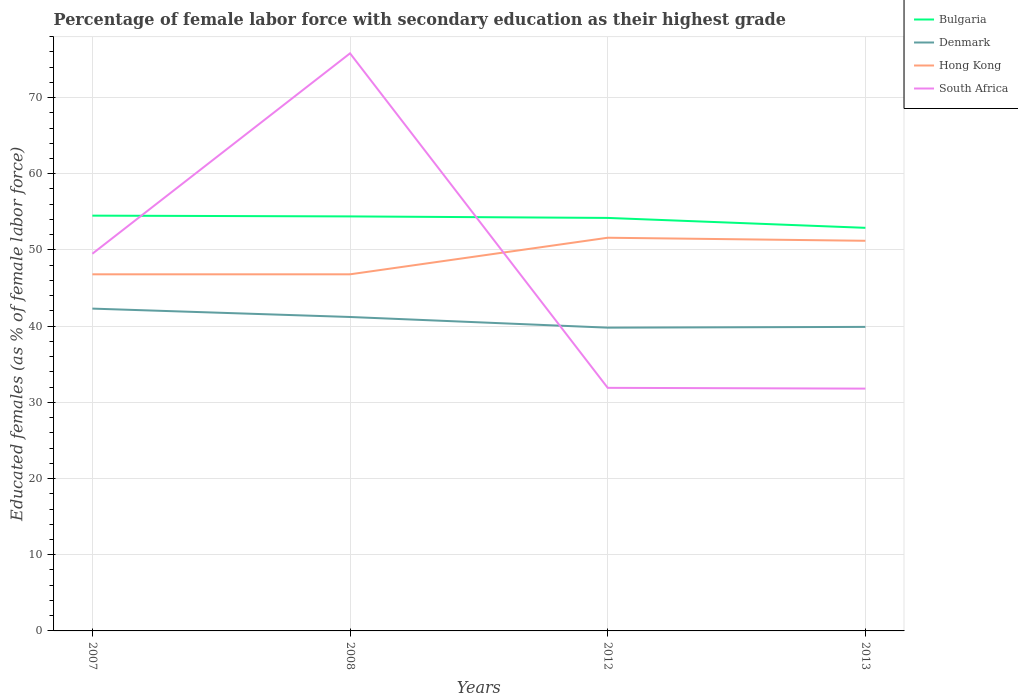How many different coloured lines are there?
Ensure brevity in your answer.  4. Across all years, what is the maximum percentage of female labor force with secondary education in Denmark?
Provide a succinct answer. 39.8. In which year was the percentage of female labor force with secondary education in Denmark maximum?
Your answer should be very brief. 2012. What is the total percentage of female labor force with secondary education in Hong Kong in the graph?
Offer a terse response. -4.4. What is the difference between the highest and the lowest percentage of female labor force with secondary education in South Africa?
Ensure brevity in your answer.  2. How many years are there in the graph?
Your answer should be compact. 4. Where does the legend appear in the graph?
Make the answer very short. Top right. How many legend labels are there?
Offer a terse response. 4. What is the title of the graph?
Give a very brief answer. Percentage of female labor force with secondary education as their highest grade. What is the label or title of the Y-axis?
Keep it short and to the point. Educated females (as % of female labor force). What is the Educated females (as % of female labor force) in Bulgaria in 2007?
Your response must be concise. 54.5. What is the Educated females (as % of female labor force) in Denmark in 2007?
Provide a short and direct response. 42.3. What is the Educated females (as % of female labor force) in Hong Kong in 2007?
Make the answer very short. 46.8. What is the Educated females (as % of female labor force) in South Africa in 2007?
Keep it short and to the point. 49.5. What is the Educated females (as % of female labor force) in Bulgaria in 2008?
Keep it short and to the point. 54.4. What is the Educated females (as % of female labor force) in Denmark in 2008?
Keep it short and to the point. 41.2. What is the Educated females (as % of female labor force) of Hong Kong in 2008?
Offer a terse response. 46.8. What is the Educated females (as % of female labor force) in South Africa in 2008?
Give a very brief answer. 75.8. What is the Educated females (as % of female labor force) of Bulgaria in 2012?
Ensure brevity in your answer.  54.2. What is the Educated females (as % of female labor force) in Denmark in 2012?
Offer a very short reply. 39.8. What is the Educated females (as % of female labor force) of Hong Kong in 2012?
Make the answer very short. 51.6. What is the Educated females (as % of female labor force) in South Africa in 2012?
Keep it short and to the point. 31.9. What is the Educated females (as % of female labor force) of Bulgaria in 2013?
Give a very brief answer. 52.9. What is the Educated females (as % of female labor force) in Denmark in 2013?
Keep it short and to the point. 39.9. What is the Educated females (as % of female labor force) of Hong Kong in 2013?
Give a very brief answer. 51.2. What is the Educated females (as % of female labor force) in South Africa in 2013?
Your response must be concise. 31.8. Across all years, what is the maximum Educated females (as % of female labor force) in Bulgaria?
Your answer should be very brief. 54.5. Across all years, what is the maximum Educated females (as % of female labor force) of Denmark?
Offer a very short reply. 42.3. Across all years, what is the maximum Educated females (as % of female labor force) in Hong Kong?
Your response must be concise. 51.6. Across all years, what is the maximum Educated females (as % of female labor force) in South Africa?
Keep it short and to the point. 75.8. Across all years, what is the minimum Educated females (as % of female labor force) of Bulgaria?
Ensure brevity in your answer.  52.9. Across all years, what is the minimum Educated females (as % of female labor force) in Denmark?
Provide a succinct answer. 39.8. Across all years, what is the minimum Educated females (as % of female labor force) of Hong Kong?
Make the answer very short. 46.8. Across all years, what is the minimum Educated females (as % of female labor force) of South Africa?
Your response must be concise. 31.8. What is the total Educated females (as % of female labor force) in Bulgaria in the graph?
Give a very brief answer. 216. What is the total Educated females (as % of female labor force) of Denmark in the graph?
Your answer should be compact. 163.2. What is the total Educated females (as % of female labor force) of Hong Kong in the graph?
Your answer should be compact. 196.4. What is the total Educated females (as % of female labor force) in South Africa in the graph?
Keep it short and to the point. 189. What is the difference between the Educated females (as % of female labor force) in Bulgaria in 2007 and that in 2008?
Your answer should be compact. 0.1. What is the difference between the Educated females (as % of female labor force) of Denmark in 2007 and that in 2008?
Your answer should be very brief. 1.1. What is the difference between the Educated females (as % of female labor force) of Hong Kong in 2007 and that in 2008?
Keep it short and to the point. 0. What is the difference between the Educated females (as % of female labor force) of South Africa in 2007 and that in 2008?
Keep it short and to the point. -26.3. What is the difference between the Educated females (as % of female labor force) of Denmark in 2007 and that in 2012?
Offer a terse response. 2.5. What is the difference between the Educated females (as % of female labor force) of South Africa in 2007 and that in 2012?
Provide a short and direct response. 17.6. What is the difference between the Educated females (as % of female labor force) of South Africa in 2007 and that in 2013?
Provide a short and direct response. 17.7. What is the difference between the Educated females (as % of female labor force) in Bulgaria in 2008 and that in 2012?
Keep it short and to the point. 0.2. What is the difference between the Educated females (as % of female labor force) of South Africa in 2008 and that in 2012?
Provide a short and direct response. 43.9. What is the difference between the Educated females (as % of female labor force) in Bulgaria in 2008 and that in 2013?
Provide a short and direct response. 1.5. What is the difference between the Educated females (as % of female labor force) of Hong Kong in 2008 and that in 2013?
Offer a terse response. -4.4. What is the difference between the Educated females (as % of female labor force) in South Africa in 2008 and that in 2013?
Your answer should be very brief. 44. What is the difference between the Educated females (as % of female labor force) in Bulgaria in 2012 and that in 2013?
Make the answer very short. 1.3. What is the difference between the Educated females (as % of female labor force) in South Africa in 2012 and that in 2013?
Provide a succinct answer. 0.1. What is the difference between the Educated females (as % of female labor force) in Bulgaria in 2007 and the Educated females (as % of female labor force) in Denmark in 2008?
Provide a succinct answer. 13.3. What is the difference between the Educated females (as % of female labor force) of Bulgaria in 2007 and the Educated females (as % of female labor force) of Hong Kong in 2008?
Provide a short and direct response. 7.7. What is the difference between the Educated females (as % of female labor force) in Bulgaria in 2007 and the Educated females (as % of female labor force) in South Africa in 2008?
Offer a very short reply. -21.3. What is the difference between the Educated females (as % of female labor force) of Denmark in 2007 and the Educated females (as % of female labor force) of South Africa in 2008?
Make the answer very short. -33.5. What is the difference between the Educated females (as % of female labor force) of Hong Kong in 2007 and the Educated females (as % of female labor force) of South Africa in 2008?
Your response must be concise. -29. What is the difference between the Educated females (as % of female labor force) in Bulgaria in 2007 and the Educated females (as % of female labor force) in South Africa in 2012?
Keep it short and to the point. 22.6. What is the difference between the Educated females (as % of female labor force) of Hong Kong in 2007 and the Educated females (as % of female labor force) of South Africa in 2012?
Your answer should be compact. 14.9. What is the difference between the Educated females (as % of female labor force) in Bulgaria in 2007 and the Educated females (as % of female labor force) in South Africa in 2013?
Your response must be concise. 22.7. What is the difference between the Educated females (as % of female labor force) in Denmark in 2007 and the Educated females (as % of female labor force) in Hong Kong in 2013?
Provide a succinct answer. -8.9. What is the difference between the Educated females (as % of female labor force) in Denmark in 2007 and the Educated females (as % of female labor force) in South Africa in 2013?
Provide a short and direct response. 10.5. What is the difference between the Educated females (as % of female labor force) of Hong Kong in 2007 and the Educated females (as % of female labor force) of South Africa in 2013?
Your answer should be very brief. 15. What is the difference between the Educated females (as % of female labor force) in Bulgaria in 2008 and the Educated females (as % of female labor force) in Denmark in 2012?
Offer a very short reply. 14.6. What is the difference between the Educated females (as % of female labor force) in Denmark in 2008 and the Educated females (as % of female labor force) in Hong Kong in 2012?
Your response must be concise. -10.4. What is the difference between the Educated females (as % of female labor force) of Denmark in 2008 and the Educated females (as % of female labor force) of South Africa in 2012?
Give a very brief answer. 9.3. What is the difference between the Educated females (as % of female labor force) in Hong Kong in 2008 and the Educated females (as % of female labor force) in South Africa in 2012?
Make the answer very short. 14.9. What is the difference between the Educated females (as % of female labor force) of Bulgaria in 2008 and the Educated females (as % of female labor force) of Hong Kong in 2013?
Your answer should be very brief. 3.2. What is the difference between the Educated females (as % of female labor force) of Bulgaria in 2008 and the Educated females (as % of female labor force) of South Africa in 2013?
Provide a short and direct response. 22.6. What is the difference between the Educated females (as % of female labor force) of Denmark in 2008 and the Educated females (as % of female labor force) of South Africa in 2013?
Your response must be concise. 9.4. What is the difference between the Educated females (as % of female labor force) of Hong Kong in 2008 and the Educated females (as % of female labor force) of South Africa in 2013?
Your response must be concise. 15. What is the difference between the Educated females (as % of female labor force) of Bulgaria in 2012 and the Educated females (as % of female labor force) of Denmark in 2013?
Your answer should be very brief. 14.3. What is the difference between the Educated females (as % of female labor force) in Bulgaria in 2012 and the Educated females (as % of female labor force) in South Africa in 2013?
Keep it short and to the point. 22.4. What is the difference between the Educated females (as % of female labor force) in Hong Kong in 2012 and the Educated females (as % of female labor force) in South Africa in 2013?
Give a very brief answer. 19.8. What is the average Educated females (as % of female labor force) in Bulgaria per year?
Provide a succinct answer. 54. What is the average Educated females (as % of female labor force) in Denmark per year?
Keep it short and to the point. 40.8. What is the average Educated females (as % of female labor force) in Hong Kong per year?
Provide a succinct answer. 49.1. What is the average Educated females (as % of female labor force) of South Africa per year?
Offer a terse response. 47.25. In the year 2007, what is the difference between the Educated females (as % of female labor force) of Bulgaria and Educated females (as % of female labor force) of South Africa?
Your response must be concise. 5. In the year 2007, what is the difference between the Educated females (as % of female labor force) in Hong Kong and Educated females (as % of female labor force) in South Africa?
Give a very brief answer. -2.7. In the year 2008, what is the difference between the Educated females (as % of female labor force) in Bulgaria and Educated females (as % of female labor force) in Denmark?
Provide a short and direct response. 13.2. In the year 2008, what is the difference between the Educated females (as % of female labor force) of Bulgaria and Educated females (as % of female labor force) of South Africa?
Your answer should be compact. -21.4. In the year 2008, what is the difference between the Educated females (as % of female labor force) of Denmark and Educated females (as % of female labor force) of Hong Kong?
Your answer should be compact. -5.6. In the year 2008, what is the difference between the Educated females (as % of female labor force) of Denmark and Educated females (as % of female labor force) of South Africa?
Give a very brief answer. -34.6. In the year 2008, what is the difference between the Educated females (as % of female labor force) in Hong Kong and Educated females (as % of female labor force) in South Africa?
Your answer should be compact. -29. In the year 2012, what is the difference between the Educated females (as % of female labor force) in Bulgaria and Educated females (as % of female labor force) in Hong Kong?
Keep it short and to the point. 2.6. In the year 2012, what is the difference between the Educated females (as % of female labor force) in Bulgaria and Educated females (as % of female labor force) in South Africa?
Your response must be concise. 22.3. In the year 2012, what is the difference between the Educated females (as % of female labor force) of Denmark and Educated females (as % of female labor force) of Hong Kong?
Make the answer very short. -11.8. In the year 2013, what is the difference between the Educated females (as % of female labor force) in Bulgaria and Educated females (as % of female labor force) in Denmark?
Your response must be concise. 13. In the year 2013, what is the difference between the Educated females (as % of female labor force) of Bulgaria and Educated females (as % of female labor force) of Hong Kong?
Keep it short and to the point. 1.7. In the year 2013, what is the difference between the Educated females (as % of female labor force) of Bulgaria and Educated females (as % of female labor force) of South Africa?
Give a very brief answer. 21.1. What is the ratio of the Educated females (as % of female labor force) of Denmark in 2007 to that in 2008?
Your answer should be compact. 1.03. What is the ratio of the Educated females (as % of female labor force) in Hong Kong in 2007 to that in 2008?
Keep it short and to the point. 1. What is the ratio of the Educated females (as % of female labor force) in South Africa in 2007 to that in 2008?
Provide a succinct answer. 0.65. What is the ratio of the Educated females (as % of female labor force) of Denmark in 2007 to that in 2012?
Ensure brevity in your answer.  1.06. What is the ratio of the Educated females (as % of female labor force) of Hong Kong in 2007 to that in 2012?
Your answer should be compact. 0.91. What is the ratio of the Educated females (as % of female labor force) in South Africa in 2007 to that in 2012?
Provide a succinct answer. 1.55. What is the ratio of the Educated females (as % of female labor force) of Bulgaria in 2007 to that in 2013?
Provide a succinct answer. 1.03. What is the ratio of the Educated females (as % of female labor force) of Denmark in 2007 to that in 2013?
Keep it short and to the point. 1.06. What is the ratio of the Educated females (as % of female labor force) of Hong Kong in 2007 to that in 2013?
Your response must be concise. 0.91. What is the ratio of the Educated females (as % of female labor force) in South Africa in 2007 to that in 2013?
Provide a succinct answer. 1.56. What is the ratio of the Educated females (as % of female labor force) of Bulgaria in 2008 to that in 2012?
Offer a terse response. 1. What is the ratio of the Educated females (as % of female labor force) in Denmark in 2008 to that in 2012?
Ensure brevity in your answer.  1.04. What is the ratio of the Educated females (as % of female labor force) in Hong Kong in 2008 to that in 2012?
Provide a succinct answer. 0.91. What is the ratio of the Educated females (as % of female labor force) in South Africa in 2008 to that in 2012?
Keep it short and to the point. 2.38. What is the ratio of the Educated females (as % of female labor force) in Bulgaria in 2008 to that in 2013?
Your response must be concise. 1.03. What is the ratio of the Educated females (as % of female labor force) of Denmark in 2008 to that in 2013?
Your response must be concise. 1.03. What is the ratio of the Educated females (as % of female labor force) of Hong Kong in 2008 to that in 2013?
Provide a short and direct response. 0.91. What is the ratio of the Educated females (as % of female labor force) of South Africa in 2008 to that in 2013?
Offer a very short reply. 2.38. What is the ratio of the Educated females (as % of female labor force) in Bulgaria in 2012 to that in 2013?
Keep it short and to the point. 1.02. What is the ratio of the Educated females (as % of female labor force) in South Africa in 2012 to that in 2013?
Provide a succinct answer. 1. What is the difference between the highest and the second highest Educated females (as % of female labor force) of Hong Kong?
Give a very brief answer. 0.4. What is the difference between the highest and the second highest Educated females (as % of female labor force) of South Africa?
Ensure brevity in your answer.  26.3. What is the difference between the highest and the lowest Educated females (as % of female labor force) in Hong Kong?
Ensure brevity in your answer.  4.8. What is the difference between the highest and the lowest Educated females (as % of female labor force) of South Africa?
Ensure brevity in your answer.  44. 